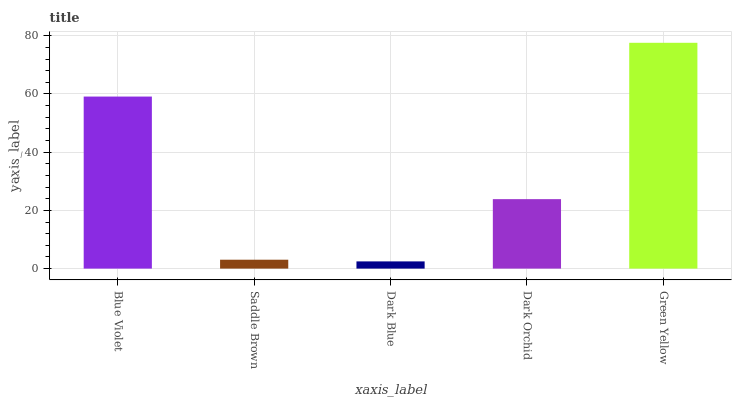Is Saddle Brown the minimum?
Answer yes or no. No. Is Saddle Brown the maximum?
Answer yes or no. No. Is Blue Violet greater than Saddle Brown?
Answer yes or no. Yes. Is Saddle Brown less than Blue Violet?
Answer yes or no. Yes. Is Saddle Brown greater than Blue Violet?
Answer yes or no. No. Is Blue Violet less than Saddle Brown?
Answer yes or no. No. Is Dark Orchid the high median?
Answer yes or no. Yes. Is Dark Orchid the low median?
Answer yes or no. Yes. Is Saddle Brown the high median?
Answer yes or no. No. Is Saddle Brown the low median?
Answer yes or no. No. 